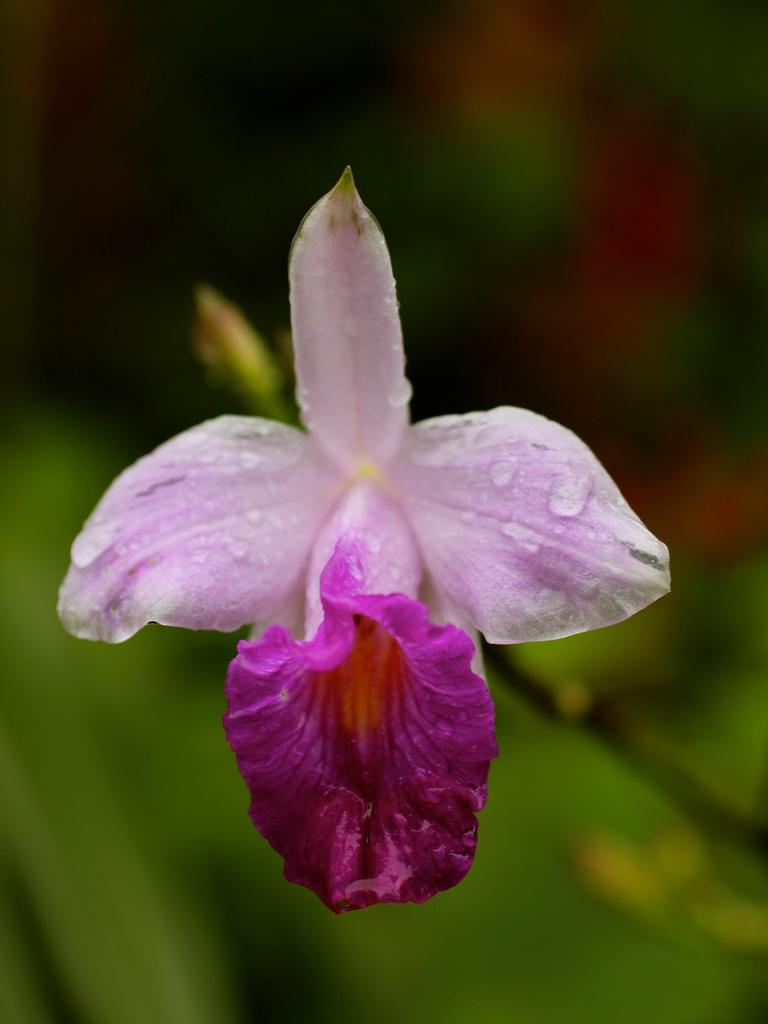What is the main subject of the image? There is a flower in the image. Can you describe the background of the image? The background of the image is blurred. How is the wood being used in the image? There is no wood present in the image; it only features a flower and a blurred background. 